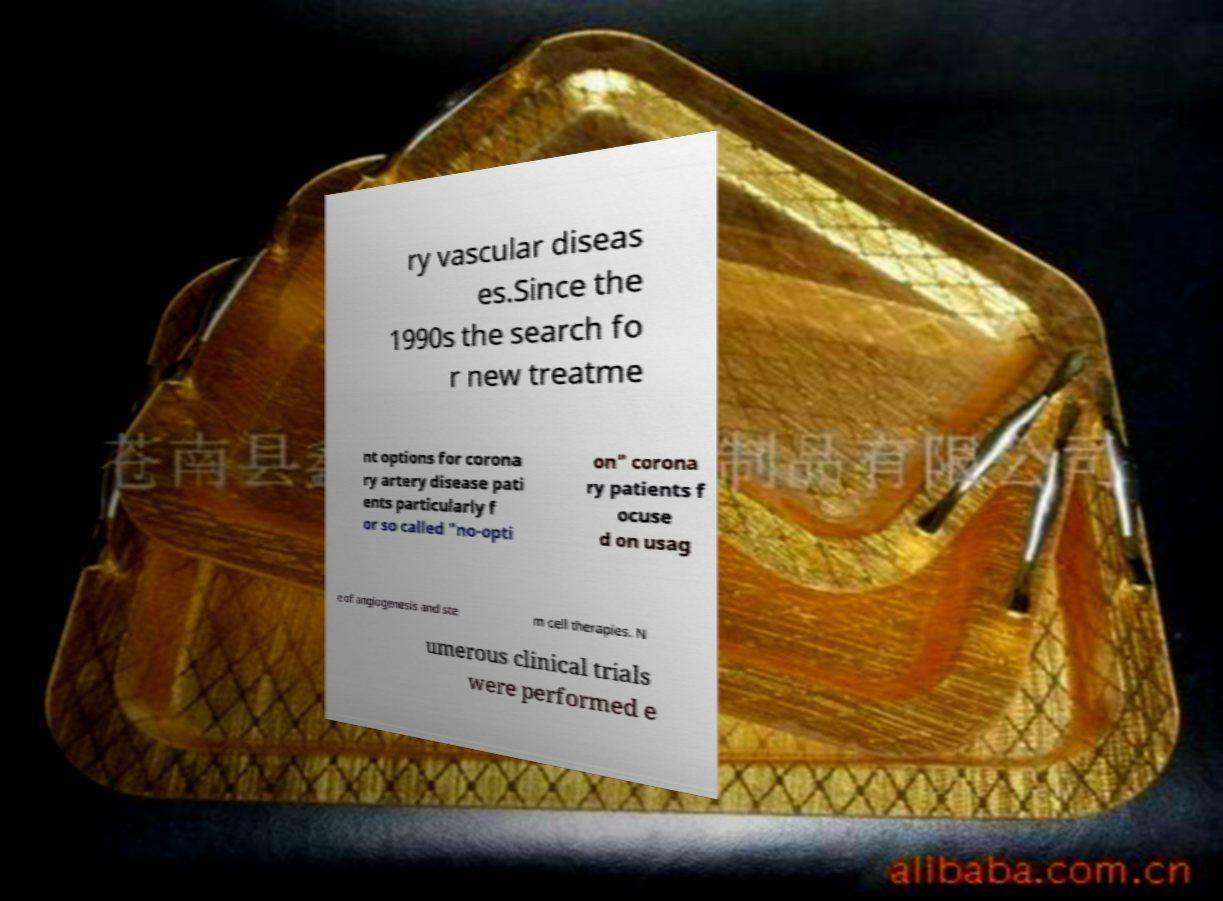I need the written content from this picture converted into text. Can you do that? ry vascular diseas es.Since the 1990s the search fo r new treatme nt options for corona ry artery disease pati ents particularly f or so called "no-opti on" corona ry patients f ocuse d on usag e of angiogenesis and ste m cell therapies. N umerous clinical trials were performed e 